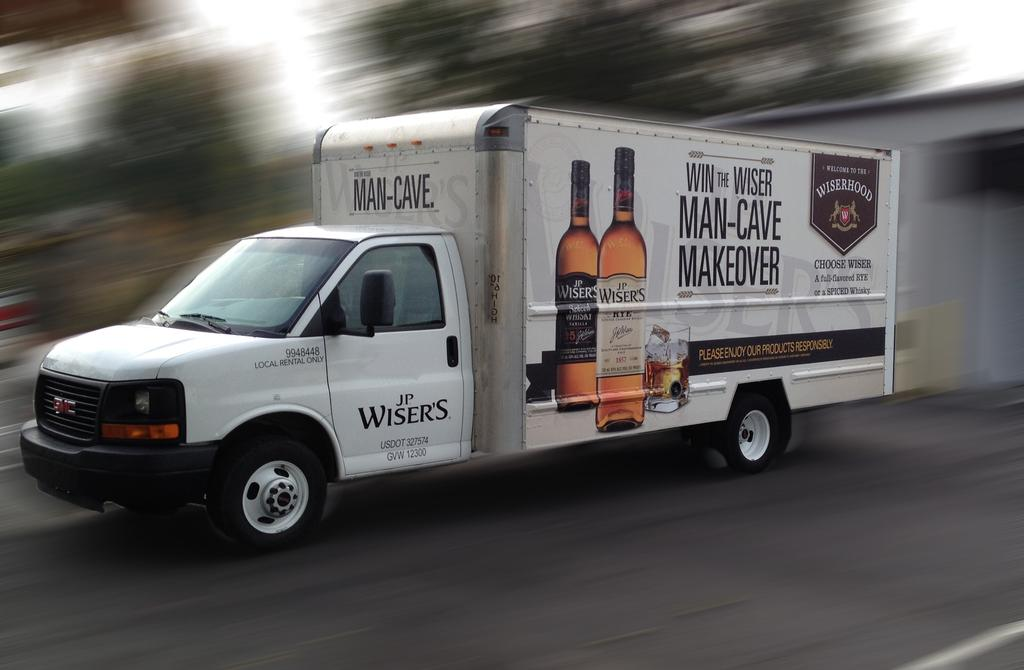<image>
Describe the image concisely. A white colored box truck carrying JL's Wisers 